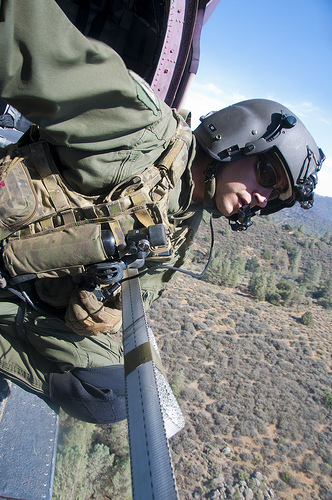<image>
Is there a solider above the ground? Yes. The solider is positioned above the ground in the vertical space, higher up in the scene. 